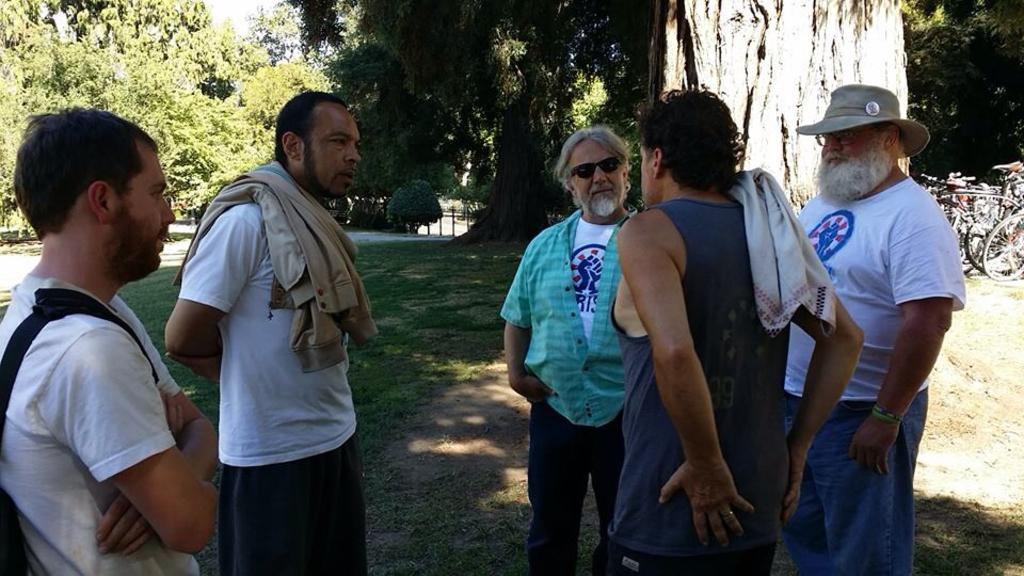What is happening with the group of people in the image? The people are standing and talking in the image. What can be seen in the background of the image? There are trees visible at the top of the image. What objects are on the right side of the image? There are bicycles on the right side of the image. Can you hear the unit coughing in the image? There is no unit or coughing present in the image; it features a group of people standing and talking. 